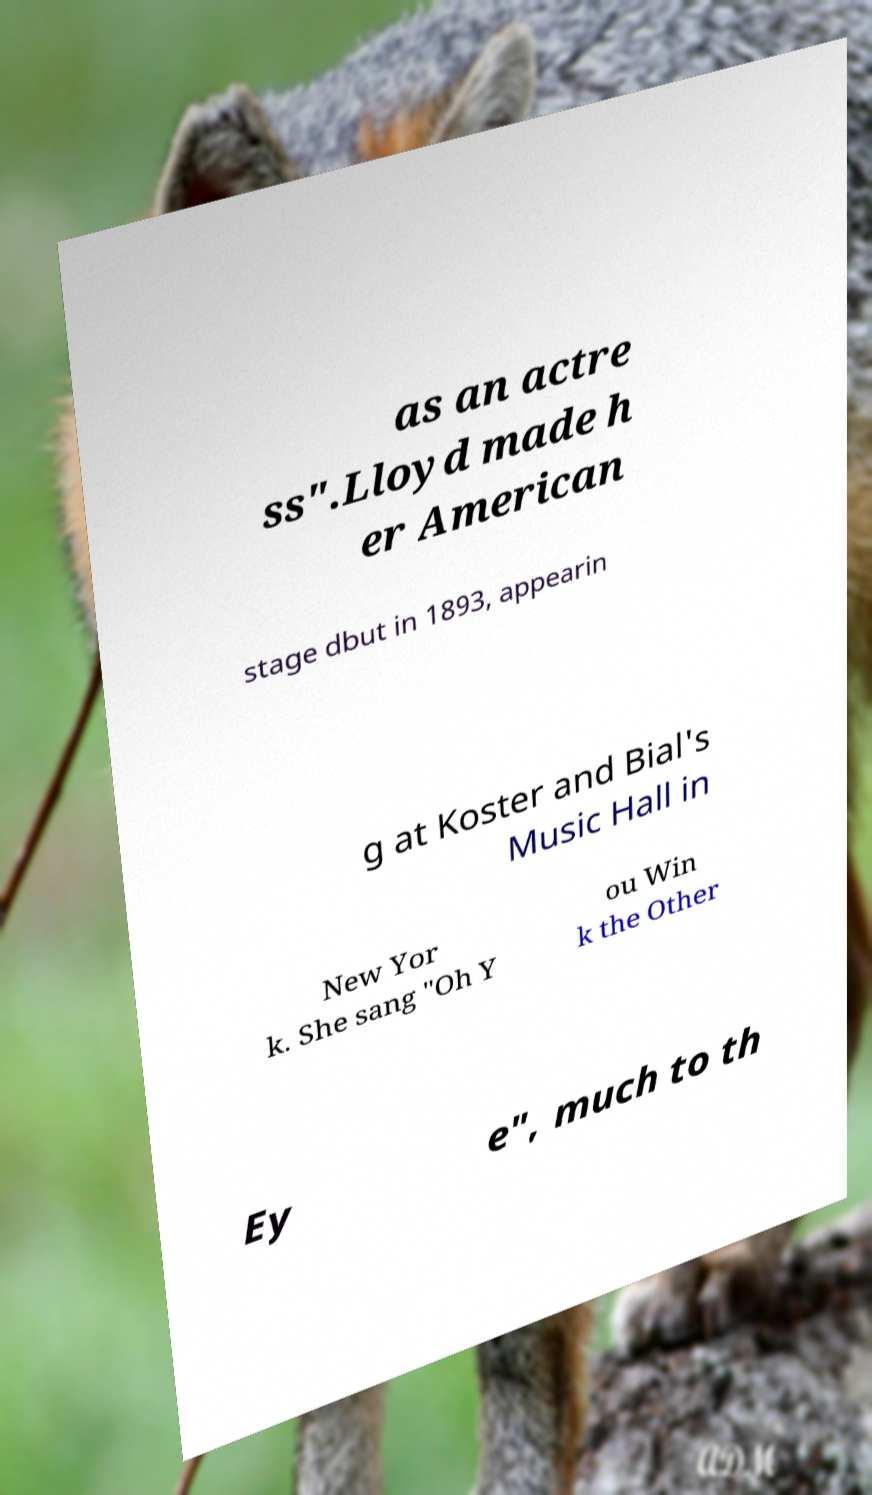What messages or text are displayed in this image? I need them in a readable, typed format. as an actre ss".Lloyd made h er American stage dbut in 1893, appearin g at Koster and Bial's Music Hall in New Yor k. She sang "Oh Y ou Win k the Other Ey e", much to th 